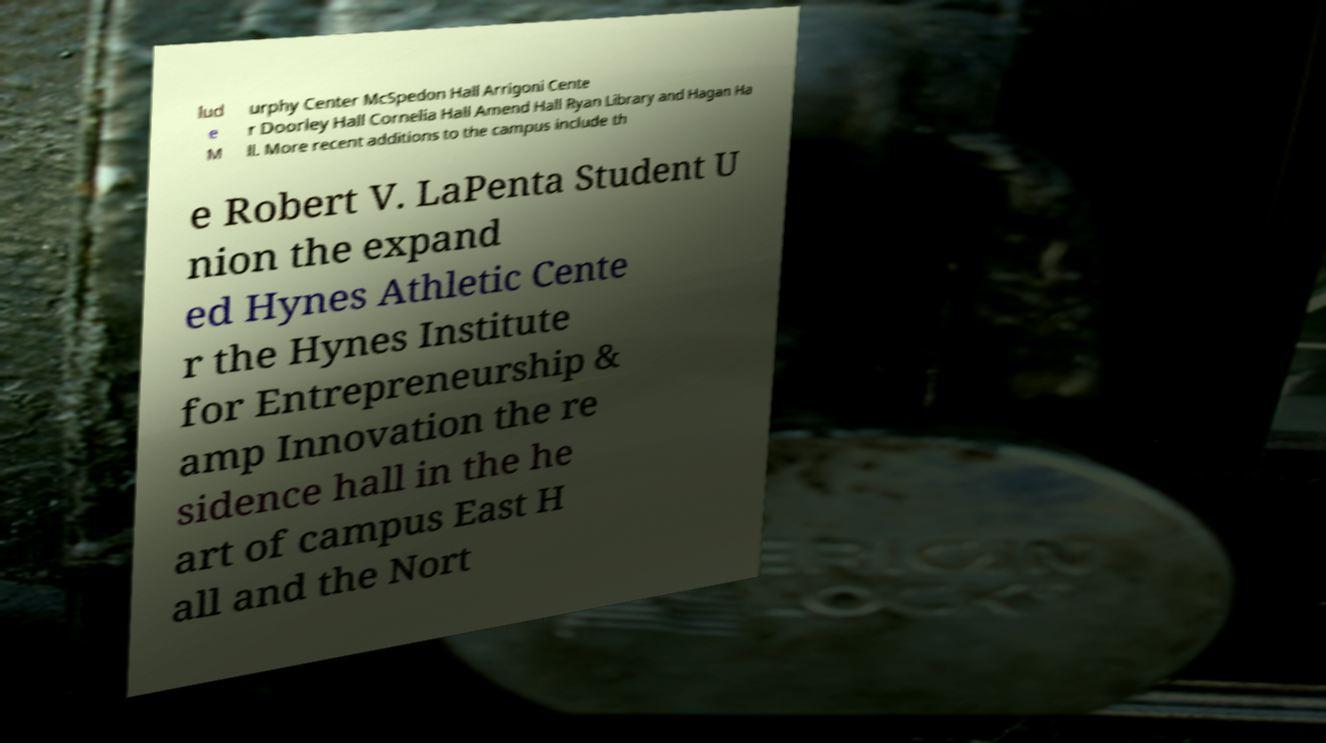Could you extract and type out the text from this image? lud e M urphy Center McSpedon Hall Arrigoni Cente r Doorley Hall Cornelia Hall Amend Hall Ryan Library and Hagan Ha ll. More recent additions to the campus include th e Robert V. LaPenta Student U nion the expand ed Hynes Athletic Cente r the Hynes Institute for Entrepreneurship & amp Innovation the re sidence hall in the he art of campus East H all and the Nort 